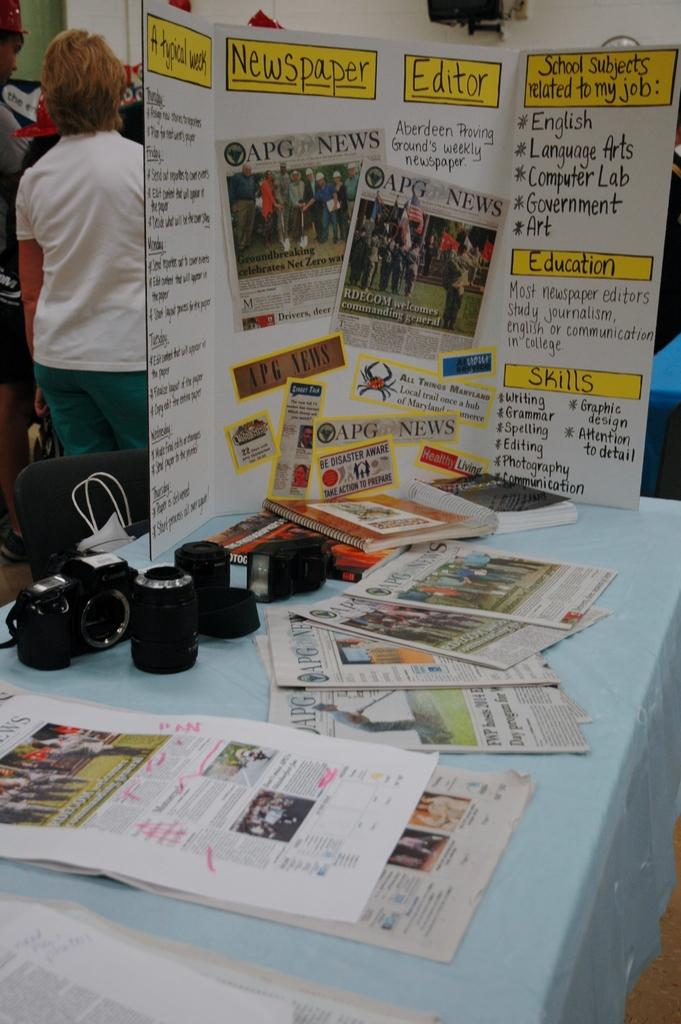<image>
Render a clear and concise summary of the photo. A display is set up on a table with the heading for newspaper and editor in the center. 